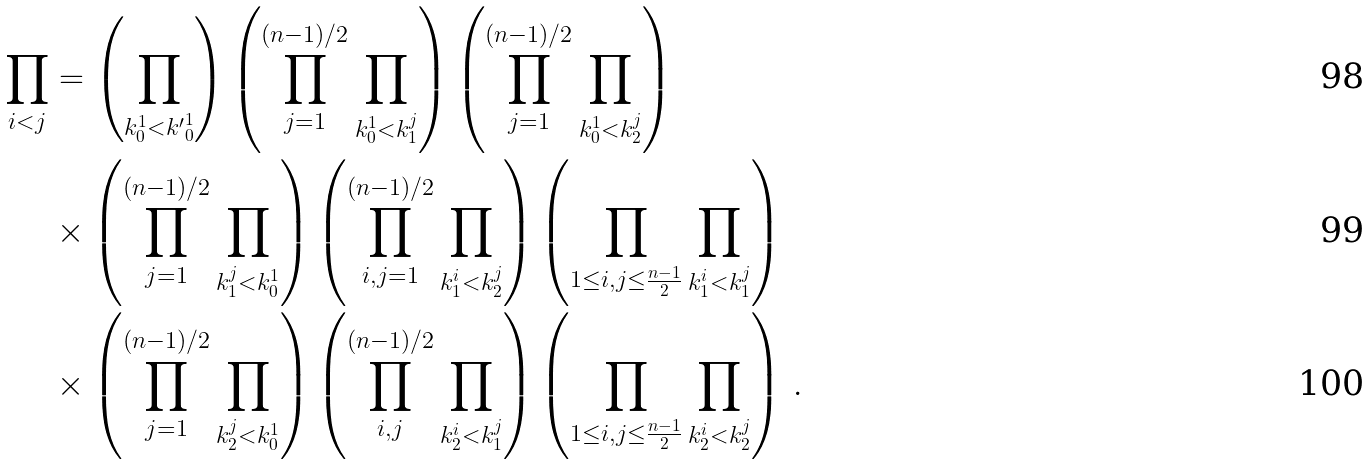Convert formula to latex. <formula><loc_0><loc_0><loc_500><loc_500>\prod _ { i < j } & = \left ( \prod _ { k ^ { 1 } _ { 0 } < { k ^ { \prime } } _ { 0 } ^ { 1 } } \right ) \left ( \prod _ { j = 1 } ^ { ( n - 1 ) / 2 } \prod _ { k ^ { 1 } _ { 0 } < k _ { 1 } ^ { j } } \right ) \left ( \prod _ { j = 1 } ^ { ( n - 1 ) / 2 } \prod _ { k _ { 0 } ^ { 1 } < k _ { 2 } ^ { j } } \right ) \\ & \times \left ( \prod _ { j = 1 } ^ { ( n - 1 ) / 2 } \prod _ { k _ { 1 } ^ { j } < k _ { 0 } ^ { 1 } } \right ) \left ( \prod _ { i , j = 1 } ^ { ( n - 1 ) / 2 } \prod _ { k _ { 1 } ^ { i } < k _ { 2 } ^ { j } } \right ) \left ( \prod _ { 1 \leq i , j \leq \frac { n - 1 } { 2 } } \prod _ { k _ { 1 } ^ { i } < k _ { 1 } ^ { j } } \right ) \\ & \times \left ( \prod _ { j = 1 } ^ { ( n - 1 ) / 2 } \prod _ { k _ { 2 } ^ { j } < k _ { 0 } ^ { 1 } } \right ) \left ( \prod _ { i , j } ^ { ( n - 1 ) / 2 } \prod _ { k _ { 2 } ^ { i } < k _ { 1 } ^ { j } } \right ) \left ( \prod _ { 1 \leq i , j \leq \frac { n - 1 } { 2 } } \prod _ { k _ { 2 } ^ { i } < k _ { 2 } ^ { j } } \right ) \, .</formula> 